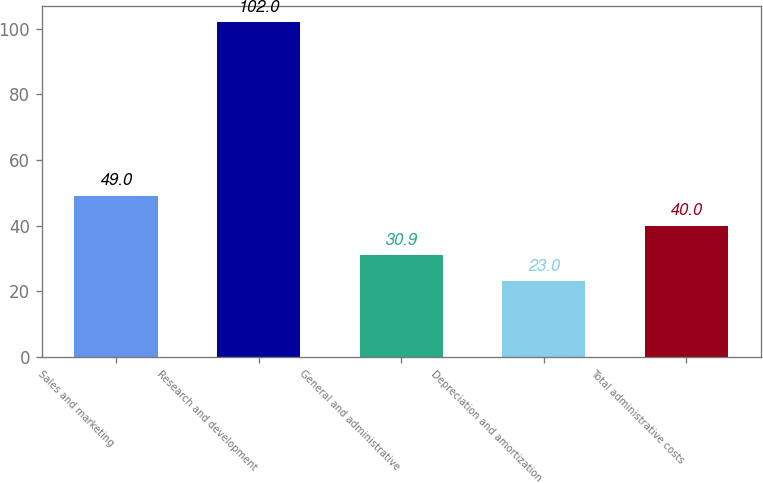Convert chart to OTSL. <chart><loc_0><loc_0><loc_500><loc_500><bar_chart><fcel>Sales and marketing<fcel>Research and development<fcel>General and administrative<fcel>Depreciation and amortization<fcel>Total administrative costs<nl><fcel>49<fcel>102<fcel>30.9<fcel>23<fcel>40<nl></chart> 